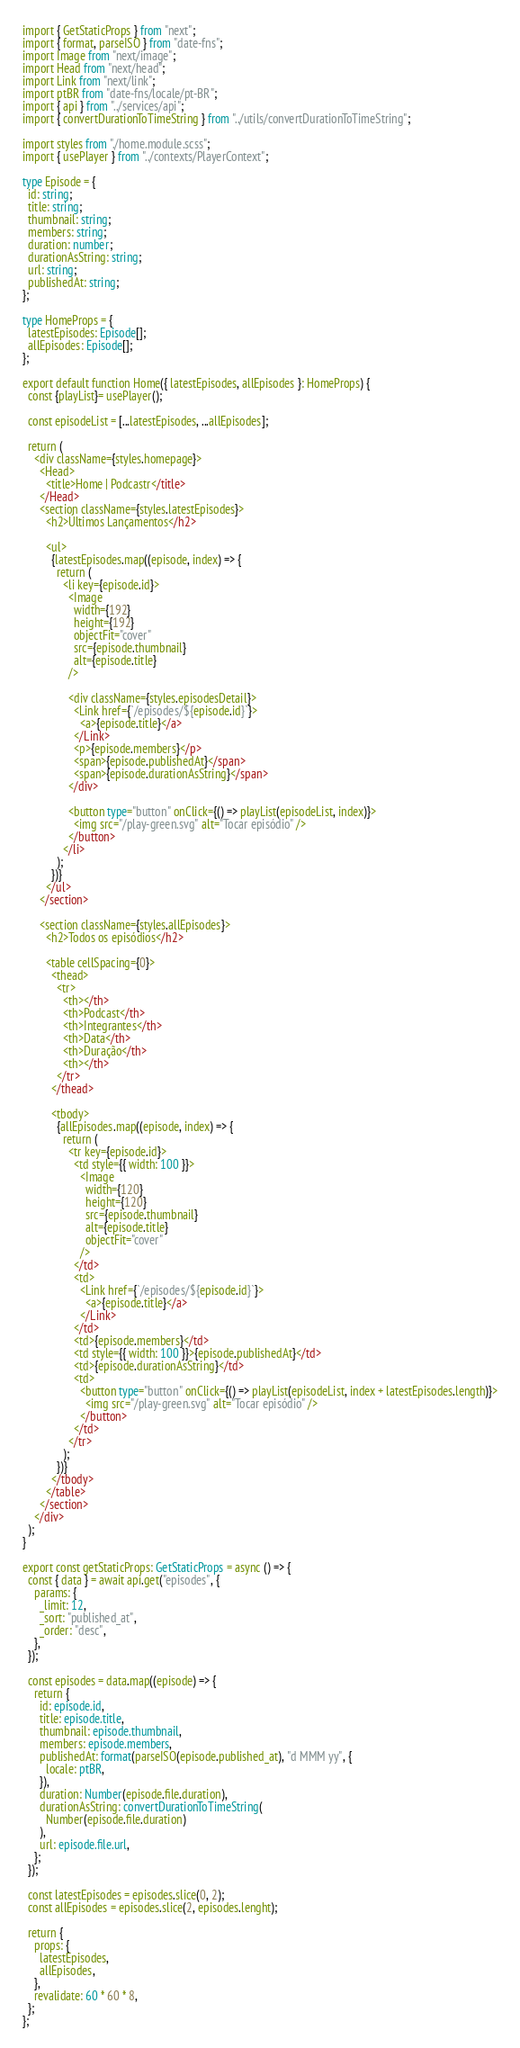<code> <loc_0><loc_0><loc_500><loc_500><_TypeScript_>import { GetStaticProps } from "next";
import { format, parseISO } from "date-fns";
import Image from "next/image";
import Head from "next/head";
import Link from "next/link";
import ptBR from "date-fns/locale/pt-BR";
import { api } from "../services/api";
import { convertDurationToTimeString } from "../utils/convertDurationToTimeString";

import styles from "./home.module.scss";
import { usePlayer } from "../contexts/PlayerContext";

type Episode = {
  id: string;
  title: string;
  thumbnail: string;
  members: string;
  duration: number;
  durationAsString: string;
  url: string;
  publishedAt: string;
};

type HomeProps = {
  latestEpisodes: Episode[];
  allEpisodes: Episode[];
};

export default function Home({ latestEpisodes, allEpisodes }: HomeProps) {
  const {playList}= usePlayer();
  
  const episodeList = [...latestEpisodes, ...allEpisodes];

  return (
    <div className={styles.homepage}>
      <Head>
        <title>Home | Podcastr</title>
      </Head>
      <section className={styles.latestEpisodes}>
        <h2>Últimos Lançamentos</h2>

        <ul>
          {latestEpisodes.map((episode, index) => {
            return (
              <li key={episode.id}>
                <Image
                  width={192}
                  height={192}
                  objectFit="cover"
                  src={episode.thumbnail}
                  alt={episode.title}
                />

                <div className={styles.episodesDetail}>
                  <Link href={`/episodes/${episode.id}`}>
                    <a>{episode.title}</a>
                  </Link>
                  <p>{episode.members}</p>
                  <span>{episode.publishedAt}</span>
                  <span>{episode.durationAsString}</span>
                </div>

                <button type="button" onClick={() => playList(episodeList, index)}>
                  <img src="/play-green.svg" alt="Tocar episódio" />
                </button>
              </li>
            );
          })}
        </ul>
      </section>

      <section className={styles.allEpisodes}>
        <h2>Todos os episódios</h2>

        <table cellSpacing={0}>
          <thead>
            <tr>
              <th></th>
              <th>Podcast</th>
              <th>Integrantes</th>
              <th>Data</th>
              <th>Duração</th>
              <th></th>
            </tr>
          </thead>

          <tbody>
            {allEpisodes.map((episode, index) => {
              return (
                <tr key={episode.id}>
                  <td style={{ width: 100 }}>
                    <Image
                      width={120}
                      height={120}
                      src={episode.thumbnail}
                      alt={episode.title}
                      objectFit="cover"
                    />
                  </td>
                  <td>
                    <Link href={`/episodes/${episode.id}`}>
                      <a>{episode.title}</a>
                    </Link>
                  </td>
                  <td>{episode.members}</td>
                  <td style={{ width: 100 }}>{episode.publishedAt}</td>
                  <td>{episode.durationAsString}</td>
                  <td>
                    <button type="button" onClick={() => playList(episodeList, index + latestEpisodes.length)}>
                      <img src="/play-green.svg" alt="Tocar episódio" />
                    </button>
                  </td>
                </tr>
              );
            })}
          </tbody>
        </table>
      </section>
    </div>
  );
}

export const getStaticProps: GetStaticProps = async () => {
  const { data } = await api.get("episodes", {
    params: {
      _limit: 12,
      _sort: "published_at",
      _order: "desc",
    },
  });

  const episodes = data.map((episode) => {
    return {
      id: episode.id,
      title: episode.title,
      thumbnail: episode.thumbnail,
      members: episode.members,
      publishedAt: format(parseISO(episode.published_at), "d MMM yy", {
        locale: ptBR,
      }),
      duration: Number(episode.file.duration),
      durationAsString: convertDurationToTimeString(
        Number(episode.file.duration)
      ),
      url: episode.file.url,
    };
  });

  const latestEpisodes = episodes.slice(0, 2);
  const allEpisodes = episodes.slice(2, episodes.lenght);

  return {
    props: {
      latestEpisodes,
      allEpisodes,
    },
    revalidate: 60 * 60 * 8,
  };
};
</code> 